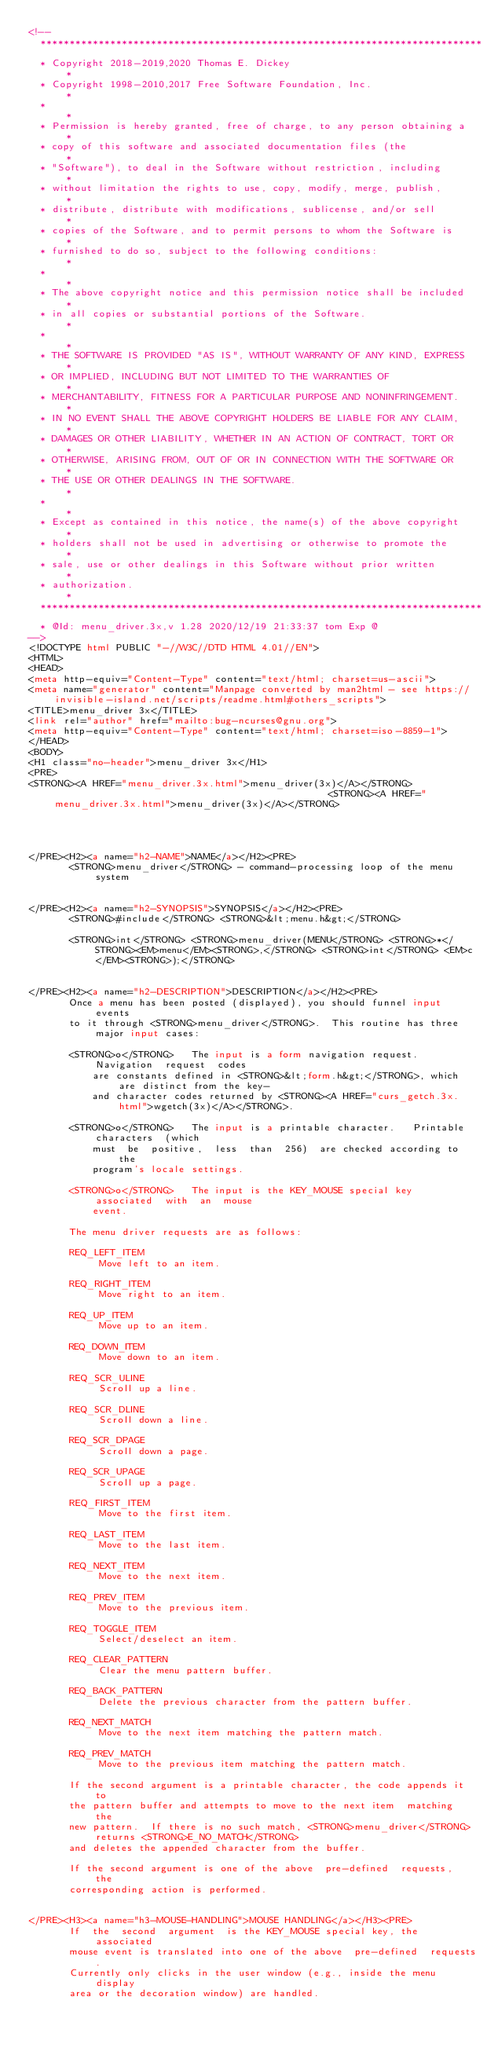Convert code to text. <code><loc_0><loc_0><loc_500><loc_500><_HTML_><!--
  ****************************************************************************
  * Copyright 2018-2019,2020 Thomas E. Dickey                                *
  * Copyright 1998-2010,2017 Free Software Foundation, Inc.                  *
  *                                                                          *
  * Permission is hereby granted, free of charge, to any person obtaining a  *
  * copy of this software and associated documentation files (the            *
  * "Software"), to deal in the Software without restriction, including      *
  * without limitation the rights to use, copy, modify, merge, publish,      *
  * distribute, distribute with modifications, sublicense, and/or sell       *
  * copies of the Software, and to permit persons to whom the Software is    *
  * furnished to do so, subject to the following conditions:                 *
  *                                                                          *
  * The above copyright notice and this permission notice shall be included  *
  * in all copies or substantial portions of the Software.                   *
  *                                                                          *
  * THE SOFTWARE IS PROVIDED "AS IS", WITHOUT WARRANTY OF ANY KIND, EXPRESS  *
  * OR IMPLIED, INCLUDING BUT NOT LIMITED TO THE WARRANTIES OF               *
  * MERCHANTABILITY, FITNESS FOR A PARTICULAR PURPOSE AND NONINFRINGEMENT.   *
  * IN NO EVENT SHALL THE ABOVE COPYRIGHT HOLDERS BE LIABLE FOR ANY CLAIM,   *
  * DAMAGES OR OTHER LIABILITY, WHETHER IN AN ACTION OF CONTRACT, TORT OR    *
  * OTHERWISE, ARISING FROM, OUT OF OR IN CONNECTION WITH THE SOFTWARE OR    *
  * THE USE OR OTHER DEALINGS IN THE SOFTWARE.                               *
  *                                                                          *
  * Except as contained in this notice, the name(s) of the above copyright   *
  * holders shall not be used in advertising or otherwise to promote the     *
  * sale, use or other dealings in this Software without prior written       *
  * authorization.                                                           *
  ****************************************************************************
  * @Id: menu_driver.3x,v 1.28 2020/12/19 21:33:37 tom Exp @
-->
<!DOCTYPE html PUBLIC "-//W3C//DTD HTML 4.01//EN">
<HTML>
<HEAD>
<meta http-equiv="Content-Type" content="text/html; charset=us-ascii">
<meta name="generator" content="Manpage converted by man2html - see https://invisible-island.net/scripts/readme.html#others_scripts">
<TITLE>menu_driver 3x</TITLE>
<link rel="author" href="mailto:bug-ncurses@gnu.org">
<meta http-equiv="Content-Type" content="text/html; charset=iso-8859-1">
</HEAD>
<BODY>
<H1 class="no-header">menu_driver 3x</H1>
<PRE>
<STRONG><A HREF="menu_driver.3x.html">menu_driver(3x)</A></STRONG>                                                <STRONG><A HREF="menu_driver.3x.html">menu_driver(3x)</A></STRONG>




</PRE><H2><a name="h2-NAME">NAME</a></H2><PRE>
       <STRONG>menu_driver</STRONG> - command-processing loop of the menu system


</PRE><H2><a name="h2-SYNOPSIS">SYNOPSIS</a></H2><PRE>
       <STRONG>#include</STRONG> <STRONG>&lt;menu.h&gt;</STRONG>

       <STRONG>int</STRONG> <STRONG>menu_driver(MENU</STRONG> <STRONG>*</STRONG><EM>menu</EM><STRONG>,</STRONG> <STRONG>int</STRONG> <EM>c</EM><STRONG>);</STRONG>


</PRE><H2><a name="h2-DESCRIPTION">DESCRIPTION</a></H2><PRE>
       Once a menu has been posted (displayed), you should funnel input events
       to it through <STRONG>menu_driver</STRONG>.  This routine has three major input cases:

       <STRONG>o</STRONG>   The input is a form navigation request.  Navigation  request  codes
           are constants defined in <STRONG>&lt;form.h&gt;</STRONG>, which are distinct from the key-
           and character codes returned by <STRONG><A HREF="curs_getch.3x.html">wgetch(3x)</A></STRONG>.

       <STRONG>o</STRONG>   The input is a printable character.   Printable  characters  (which
           must  be  positive,  less  than  256)  are checked according to the
           program's locale settings.

       <STRONG>o</STRONG>   The input is the KEY_MOUSE special key  associated  with  an  mouse
           event.

       The menu driver requests are as follows:

       REQ_LEFT_ITEM
            Move left to an item.

       REQ_RIGHT_ITEM
            Move right to an item.

       REQ_UP_ITEM
            Move up to an item.

       REQ_DOWN_ITEM
            Move down to an item.

       REQ_SCR_ULINE
            Scroll up a line.

       REQ_SCR_DLINE
            Scroll down a line.

       REQ_SCR_DPAGE
            Scroll down a page.

       REQ_SCR_UPAGE
            Scroll up a page.

       REQ_FIRST_ITEM
            Move to the first item.

       REQ_LAST_ITEM
            Move to the last item.

       REQ_NEXT_ITEM
            Move to the next item.

       REQ_PREV_ITEM
            Move to the previous item.

       REQ_TOGGLE_ITEM
            Select/deselect an item.

       REQ_CLEAR_PATTERN
            Clear the menu pattern buffer.

       REQ_BACK_PATTERN
            Delete the previous character from the pattern buffer.

       REQ_NEXT_MATCH
            Move to the next item matching the pattern match.

       REQ_PREV_MATCH
            Move to the previous item matching the pattern match.

       If the second argument is a printable character, the code appends it to
       the pattern buffer and attempts to move to the next item  matching  the
       new pattern.  If there is no such match, <STRONG>menu_driver</STRONG> returns <STRONG>E_NO_MATCH</STRONG>
       and deletes the appended character from the buffer.

       If the second argument is one of the above  pre-defined  requests,  the
       corresponding action is performed.


</PRE><H3><a name="h3-MOUSE-HANDLING">MOUSE HANDLING</a></H3><PRE>
       If  the  second  argument  is the KEY_MOUSE special key, the associated
       mouse event is translated into one of the above  pre-defined  requests.
       Currently only clicks in the user window (e.g., inside the menu display
       area or the decoration window) are handled.
</code> 